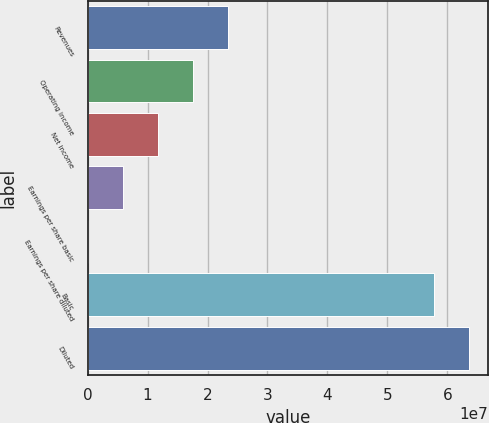<chart> <loc_0><loc_0><loc_500><loc_500><bar_chart><fcel>Revenues<fcel>Operating income<fcel>Net income<fcel>Earnings per share basic<fcel>Earnings per share diluted<fcel>Basic<fcel>Diluted<nl><fcel>2.34955e+07<fcel>1.76216e+07<fcel>1.17477e+07<fcel>5.87387e+06<fcel>0.7<fcel>5.7793e+07<fcel>6.36669e+07<nl></chart> 